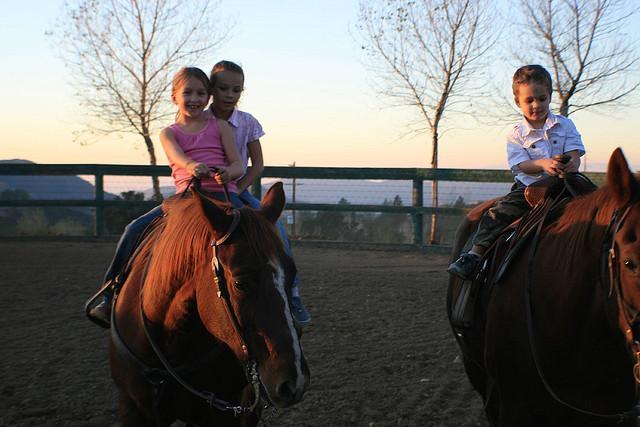How many kids are there?
Give a very brief answer. 3. How many are on the left horse?
Give a very brief answer. 2. How many people are there?
Give a very brief answer. 3. How many horses are in the picture?
Give a very brief answer. 2. 